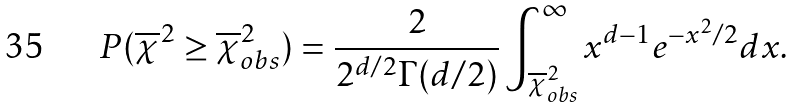Convert formula to latex. <formula><loc_0><loc_0><loc_500><loc_500>P ( \overline { \chi } ^ { 2 } \geq \overline { \chi } ^ { 2 } _ { o b s } ) = \frac { 2 } { 2 ^ { d / 2 } \Gamma ( d / 2 ) } \int ^ { \infty } _ { \overline { \chi } ^ { 2 } _ { o b s } } x ^ { d - 1 } e ^ { - x ^ { 2 } / 2 } d x .</formula> 